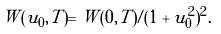Convert formula to latex. <formula><loc_0><loc_0><loc_500><loc_500>W ( u _ { 0 } , T ) = W ( 0 , T ) / ( 1 + u _ { 0 } ^ { 2 } ) ^ { 2 } .</formula> 